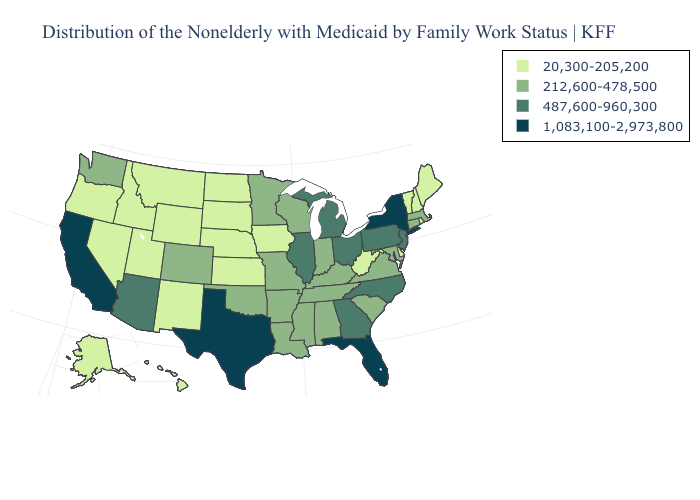Which states have the highest value in the USA?
Answer briefly. California, Florida, New York, Texas. What is the value of Alabama?
Short answer required. 212,600-478,500. What is the highest value in states that border Arizona?
Concise answer only. 1,083,100-2,973,800. Does New York have the highest value in the Northeast?
Short answer required. Yes. What is the value of Colorado?
Short answer required. 212,600-478,500. Among the states that border Indiana , which have the lowest value?
Short answer required. Kentucky. Name the states that have a value in the range 1,083,100-2,973,800?
Give a very brief answer. California, Florida, New York, Texas. Does South Carolina have a lower value than New Jersey?
Give a very brief answer. Yes. Name the states that have a value in the range 487,600-960,300?
Answer briefly. Arizona, Georgia, Illinois, Michigan, New Jersey, North Carolina, Ohio, Pennsylvania. Which states hav the highest value in the Northeast?
Be succinct. New York. Which states have the lowest value in the USA?
Short answer required. Alaska, Delaware, Hawaii, Idaho, Iowa, Kansas, Maine, Montana, Nebraska, Nevada, New Hampshire, New Mexico, North Dakota, Oregon, Rhode Island, South Dakota, Utah, Vermont, West Virginia, Wyoming. Name the states that have a value in the range 1,083,100-2,973,800?
Keep it brief. California, Florida, New York, Texas. Name the states that have a value in the range 212,600-478,500?
Short answer required. Alabama, Arkansas, Colorado, Connecticut, Indiana, Kentucky, Louisiana, Maryland, Massachusetts, Minnesota, Mississippi, Missouri, Oklahoma, South Carolina, Tennessee, Virginia, Washington, Wisconsin. What is the value of Wyoming?
Write a very short answer. 20,300-205,200. Name the states that have a value in the range 487,600-960,300?
Concise answer only. Arizona, Georgia, Illinois, Michigan, New Jersey, North Carolina, Ohio, Pennsylvania. 